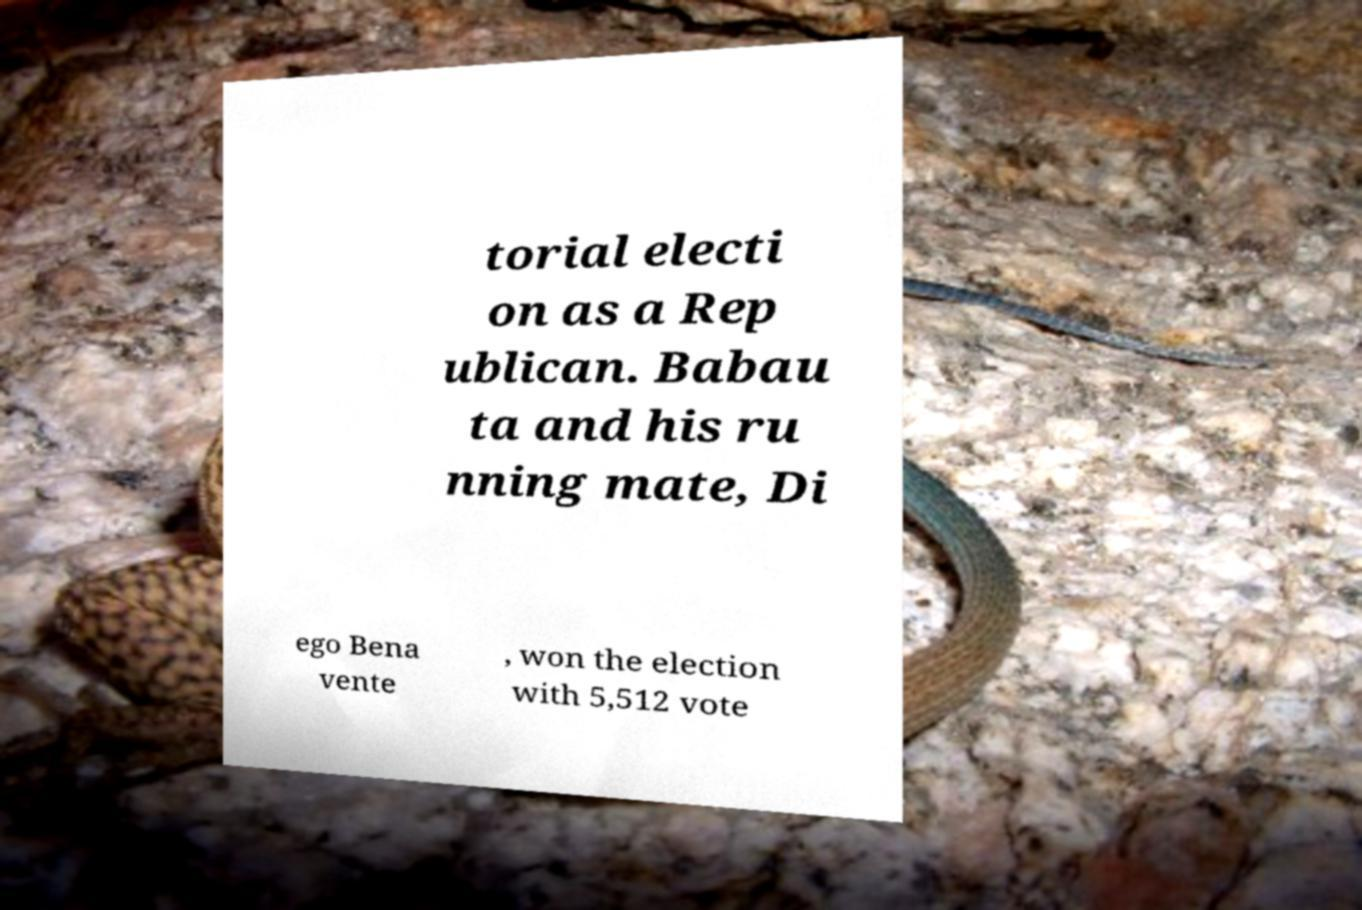For documentation purposes, I need the text within this image transcribed. Could you provide that? torial electi on as a Rep ublican. Babau ta and his ru nning mate, Di ego Bena vente , won the election with 5,512 vote 